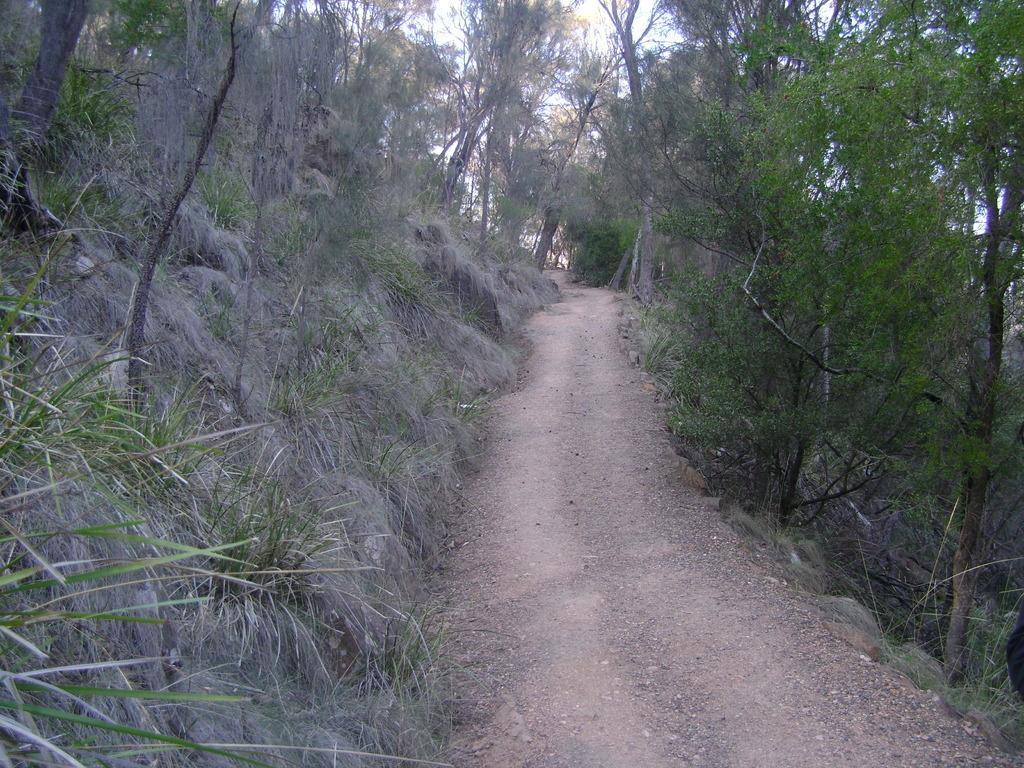Can you describe this image briefly? This picture is taken from outside of the city. In this image, on the right side, we can see some trees and plants. On the left side, we can see some trees and plants. In the background, we can see some trees. At the top, we can see a sky, we can see a land with some stones and plants. 